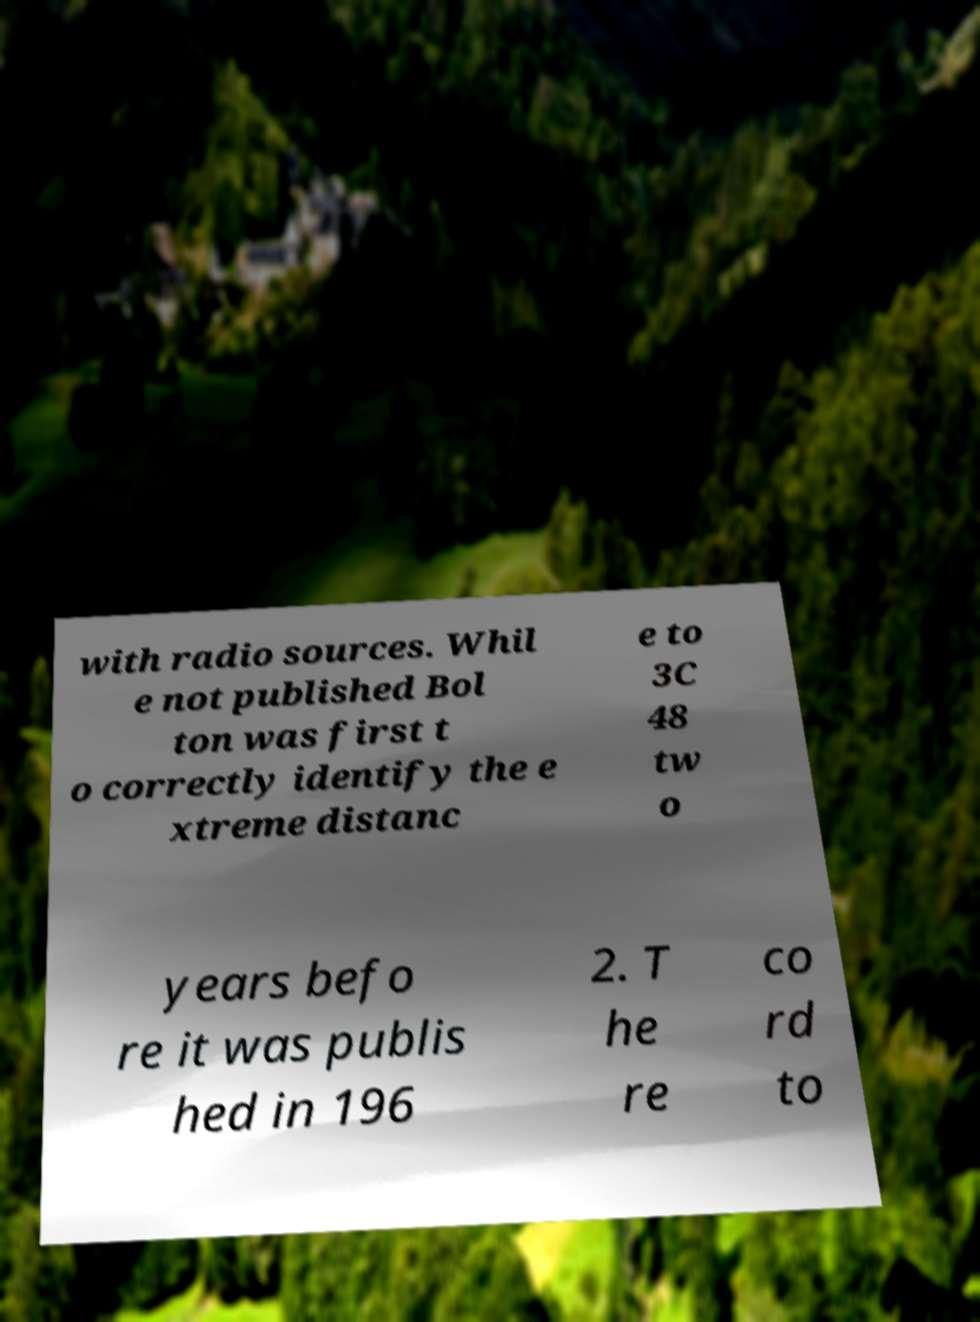For documentation purposes, I need the text within this image transcribed. Could you provide that? with radio sources. Whil e not published Bol ton was first t o correctly identify the e xtreme distanc e to 3C 48 tw o years befo re it was publis hed in 196 2. T he re co rd to 